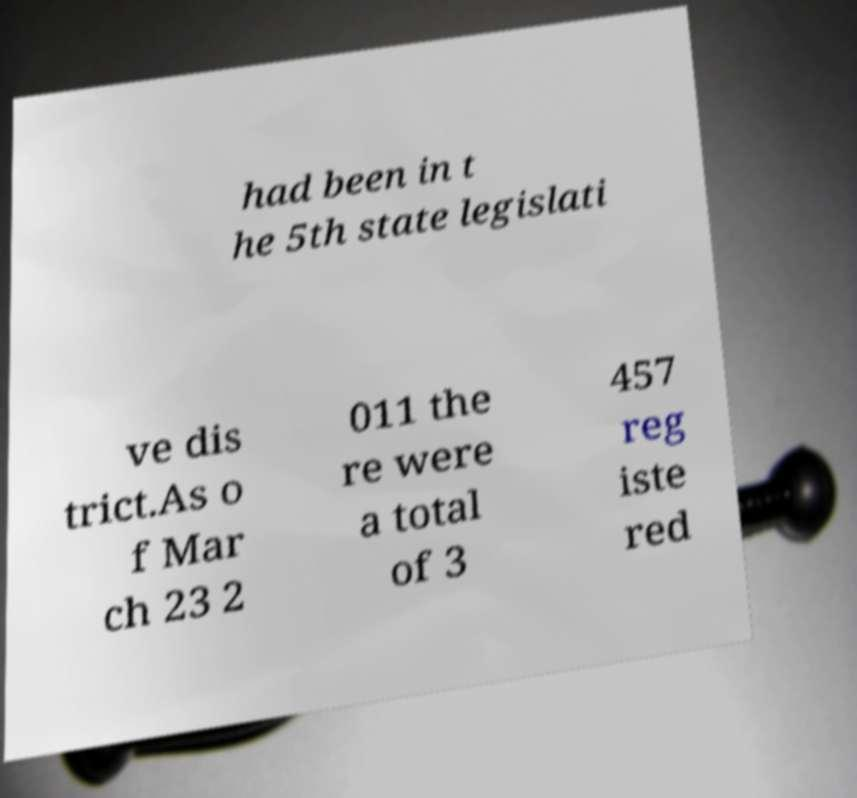What messages or text are displayed in this image? I need them in a readable, typed format. had been in t he 5th state legislati ve dis trict.As o f Mar ch 23 2 011 the re were a total of 3 457 reg iste red 